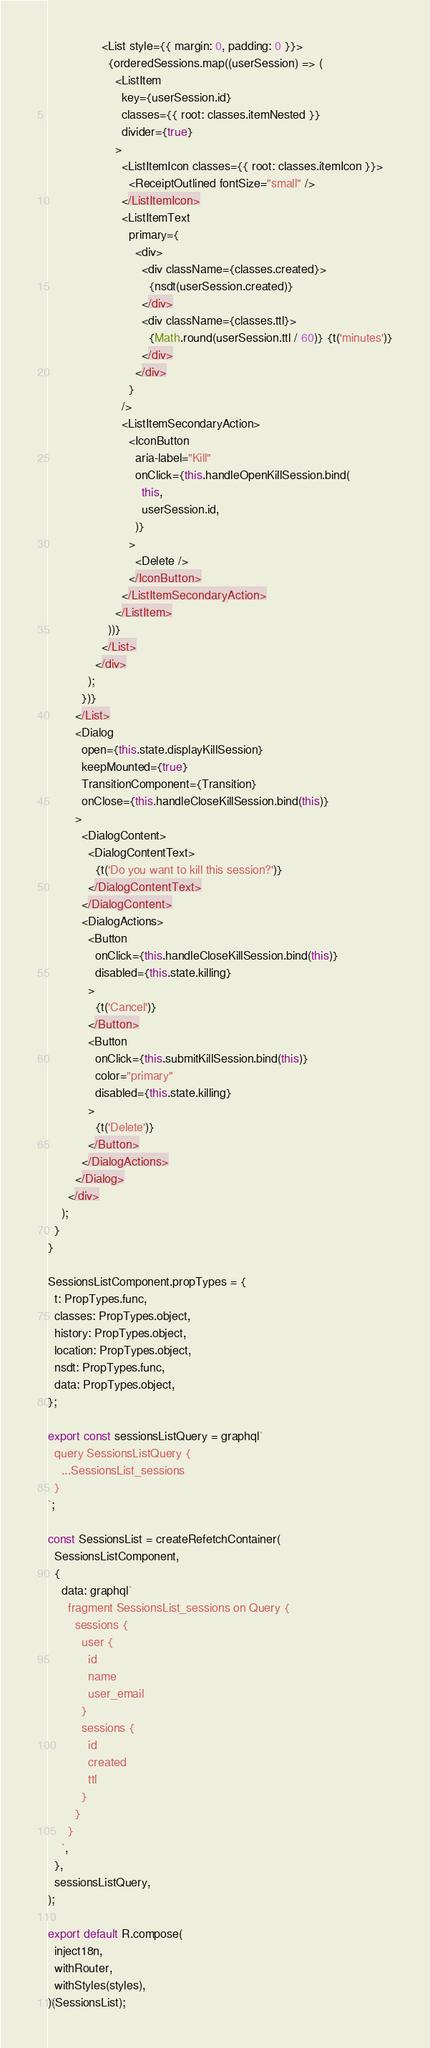<code> <loc_0><loc_0><loc_500><loc_500><_JavaScript_>                <List style={{ margin: 0, padding: 0 }}>
                  {orderedSessions.map((userSession) => (
                    <ListItem
                      key={userSession.id}
                      classes={{ root: classes.itemNested }}
                      divider={true}
                    >
                      <ListItemIcon classes={{ root: classes.itemIcon }}>
                        <ReceiptOutlined fontSize="small" />
                      </ListItemIcon>
                      <ListItemText
                        primary={
                          <div>
                            <div className={classes.created}>
                              {nsdt(userSession.created)}
                            </div>
                            <div className={classes.ttl}>
                              {Math.round(userSession.ttl / 60)} {t('minutes')}
                            </div>
                          </div>
                        }
                      />
                      <ListItemSecondaryAction>
                        <IconButton
                          aria-label="Kill"
                          onClick={this.handleOpenKillSession.bind(
                            this,
                            userSession.id,
                          )}
                        >
                          <Delete />
                        </IconButton>
                      </ListItemSecondaryAction>
                    </ListItem>
                  ))}
                </List>
              </div>
            );
          })}
        </List>
        <Dialog
          open={this.state.displayKillSession}
          keepMounted={true}
          TransitionComponent={Transition}
          onClose={this.handleCloseKillSession.bind(this)}
        >
          <DialogContent>
            <DialogContentText>
              {t('Do you want to kill this session?')}
            </DialogContentText>
          </DialogContent>
          <DialogActions>
            <Button
              onClick={this.handleCloseKillSession.bind(this)}
              disabled={this.state.killing}
            >
              {t('Cancel')}
            </Button>
            <Button
              onClick={this.submitKillSession.bind(this)}
              color="primary"
              disabled={this.state.killing}
            >
              {t('Delete')}
            </Button>
          </DialogActions>
        </Dialog>
      </div>
    );
  }
}

SessionsListComponent.propTypes = {
  t: PropTypes.func,
  classes: PropTypes.object,
  history: PropTypes.object,
  location: PropTypes.object,
  nsdt: PropTypes.func,
  data: PropTypes.object,
};

export const sessionsListQuery = graphql`
  query SessionsListQuery {
    ...SessionsList_sessions
  }
`;

const SessionsList = createRefetchContainer(
  SessionsListComponent,
  {
    data: graphql`
      fragment SessionsList_sessions on Query {
        sessions {
          user {
            id
            name
            user_email
          }
          sessions {
            id
            created
            ttl
          }
        }
      }
    `,
  },
  sessionsListQuery,
);

export default R.compose(
  inject18n,
  withRouter,
  withStyles(styles),
)(SessionsList);
</code> 